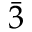Convert formula to latex. <formula><loc_0><loc_0><loc_500><loc_500>\bar { 3 }</formula> 